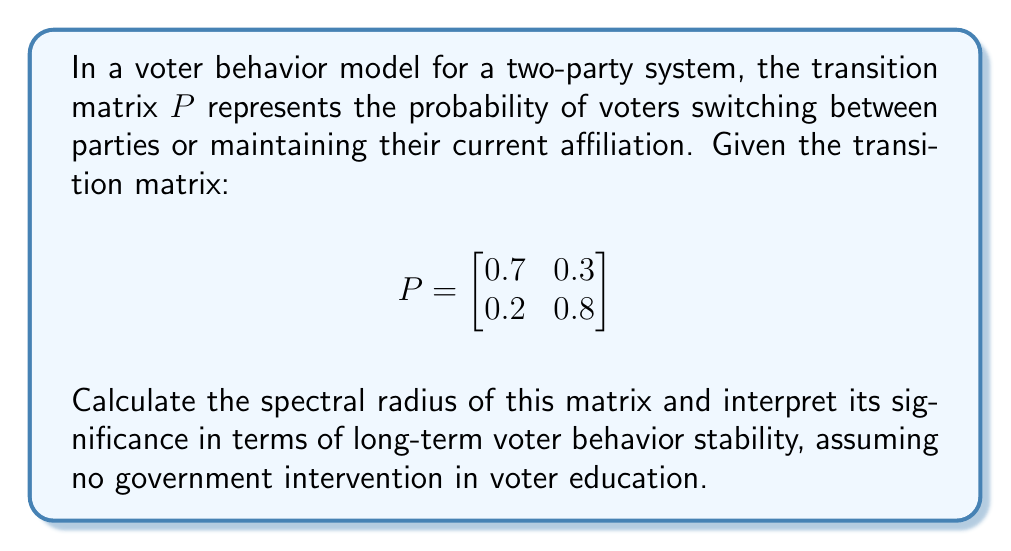Give your solution to this math problem. To find the spectral radius of the transition matrix $P$, we follow these steps:

1) First, calculate the eigenvalues of $P$. The characteristic equation is:

   $\det(P - \lambda I) = 0$

   $\begin{vmatrix}
   0.7 - \lambda & 0.3 \\
   0.2 & 0.8 - \lambda
   \end{vmatrix} = 0$

2) Expand the determinant:

   $(0.7 - \lambda)(0.8 - \lambda) - 0.06 = 0$
   $\lambda^2 - 1.5\lambda + 0.5 = 0$

3) Solve this quadratic equation:

   $\lambda = \frac{1.5 \pm \sqrt{1.5^2 - 4(0.5)}}{2}$
   $\lambda = \frac{1.5 \pm \sqrt{1.25}}{2}$
   $\lambda_1 = 1$ and $\lambda_2 = 0.5$

4) The spectral radius $\rho(P)$ is the largest absolute eigenvalue:

   $\rho(P) = \max(|\lambda_1|, |\lambda_2|) = 1$

5) Interpretation: The spectral radius of 1 indicates that the Markov chain is ergodic and has a unique stationary distribution. This means that, in the long run, the voter distribution will converge to a stable equilibrium, regardless of the initial distribution.

   In the context of the given persona, this stability suggests that even without government intervention in voter education, the two-party system will naturally reach a steady state. This could be used to argue that government involvement in education is unnecessary for maintaining political stability.
Answer: $\rho(P) = 1$ 